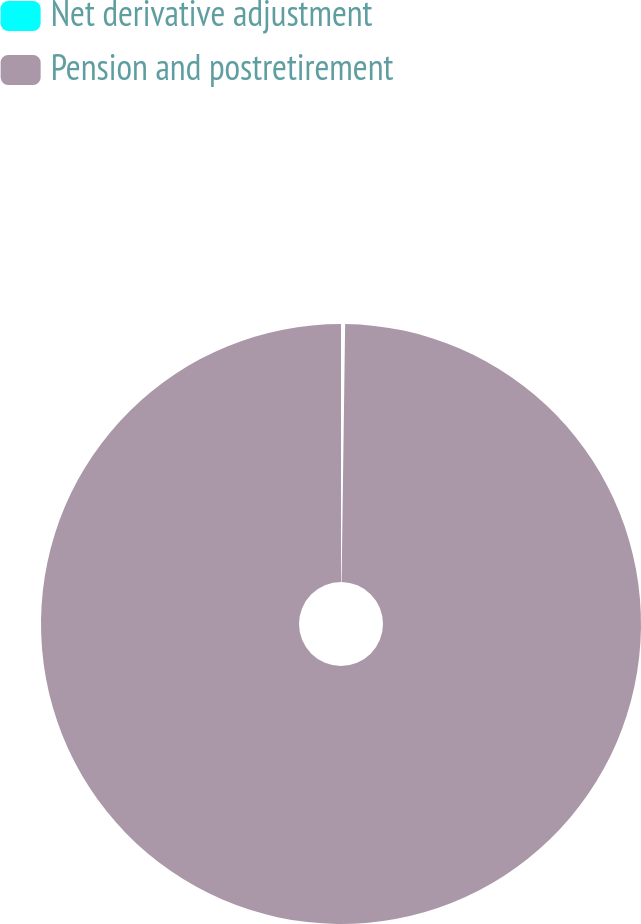<chart> <loc_0><loc_0><loc_500><loc_500><pie_chart><fcel>Net derivative adjustment<fcel>Pension and postretirement<nl><fcel>0.22%<fcel>99.78%<nl></chart> 